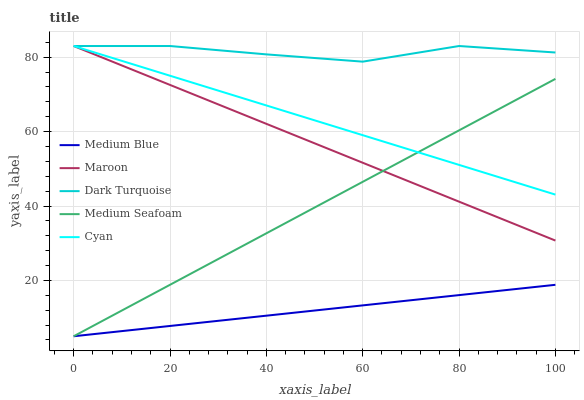Does Medium Blue have the minimum area under the curve?
Answer yes or no. Yes. Does Dark Turquoise have the maximum area under the curve?
Answer yes or no. Yes. Does Medium Seafoam have the minimum area under the curve?
Answer yes or no. No. Does Medium Seafoam have the maximum area under the curve?
Answer yes or no. No. Is Medium Blue the smoothest?
Answer yes or no. Yes. Is Dark Turquoise the roughest?
Answer yes or no. Yes. Is Medium Seafoam the smoothest?
Answer yes or no. No. Is Medium Seafoam the roughest?
Answer yes or no. No. Does Medium Blue have the lowest value?
Answer yes or no. Yes. Does Maroon have the lowest value?
Answer yes or no. No. Does Cyan have the highest value?
Answer yes or no. Yes. Does Medium Seafoam have the highest value?
Answer yes or no. No. Is Medium Blue less than Cyan?
Answer yes or no. Yes. Is Dark Turquoise greater than Medium Seafoam?
Answer yes or no. Yes. Does Cyan intersect Medium Seafoam?
Answer yes or no. Yes. Is Cyan less than Medium Seafoam?
Answer yes or no. No. Is Cyan greater than Medium Seafoam?
Answer yes or no. No. Does Medium Blue intersect Cyan?
Answer yes or no. No. 